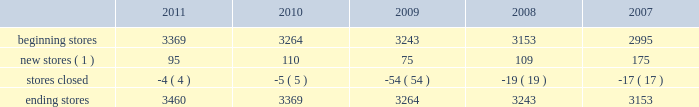The table sets forth information concerning increases in the total number of our aap stores during the past five years : beginning stores new stores ( 1 ) stores closed ending stores ( 1 ) does not include stores that opened as relocations of previously existing stores within the same general market area or substantial renovations of stores .
Our store-based information systems , which are designed to improve the efficiency of our operations and enhance customer service , are comprised of a proprietary pos system and electronic parts catalog , or epc , system .
Information maintained by our pos system is used to formulate pricing , marketing and merchandising strategies and to replenish inventory accurately and rapidly .
Our pos system is fully integrated with our epc system and enables our store team members to assist our customers in their parts selection and ordering based on the year , make , model and engine type of their vehicles .
Our centrally-based epc data management system enables us to reduce the time needed to ( i ) exchange data with our vendors and ( ii ) catalog and deliver updated , accurate parts information .
Our epc system also contains enhanced search engines and user-friendly navigation tools that enhance our team members' ability to look up any needed parts as well as additional products the customer needs to complete an automotive repair project .
If a hard-to-find part or accessory is not available at one of our stores , the epc system can determine whether the part is carried and in-stock through our hub or pdq ae networks or can be ordered directly from one of our vendors .
Available parts and accessories are then ordered electronically from another store , hub , pdq ae or directly from the vendor with immediate confirmation of price , availability and estimated delivery time .
We also support our store operations with additional proprietary systems and customer driven labor scheduling capabilities .
Our store-level inventory management system provides real-time inventory tracking at the store level .
With the store-level system , store team members can check the quantity of on-hand inventory for any sku , adjust stock levels for select items for store specific events , automatically process returns and defective merchandise , designate skus for cycle counts and track merchandise transfers .
Our stores use radio frequency hand-held devices to help ensure the accuracy of our inventory .
Our standard operating procedure , or sop , system is a web-based , electronic data management system that provides our team members with instant access to any of our standard operating procedures through a comprehensive on-line search function .
All of these systems are tightly integrated and provide real-time , comprehensive information to store personnel , resulting in improved customer service levels , team member productivity and in-stock availability .
Purchasing for virtually all of the merchandise for our stores is handled by our merchandise teams located in three primary locations : 2022 store support center in roanoke , virginia ; 2022 regional office in minneapolis , minnesota ; and 2022 global sourcing office in taipei , taiwan .
Our roanoke team is primarily responsible for the parts categories and our minnesota team is primarily responsible for accessories , oil and chemicals .
Our global sourcing team works closely with both teams .
In fiscal 2011 , we purchased merchandise from approximately 500 vendors , with no single vendor accounting for more than 9% ( 9 % ) of purchases .
Our purchasing strategy involves negotiating agreements with most of our vendors to purchase merchandise over a specified period of time along with other terms , including pricing , payment terms and volume .
The merchandising team has developed strong vendor relationships in the industry and , in a collaborative effort with our vendor partners , utilizes a category management process where we manage the mix of our product offerings to meet customer demand .
We believe this process , which develops a customer-focused business plan for each merchandise category , and our global sourcing operation are critical to improving comparable store sales , gross margin and inventory productivity. .
The following table sets forth information concerning increases in the total number of our aap stores during the past five years : beginning stores new stores ( 1 ) stores closed ending stores ( 1 ) does not include stores that opened as relocations of previously existing stores within the same general market area or substantial renovations of stores .
Our store-based information systems , which are designed to improve the efficiency of our operations and enhance customer service , are comprised of a proprietary pos system and electronic parts catalog , or epc , system .
Information maintained by our pos system is used to formulate pricing , marketing and merchandising strategies and to replenish inventory accurately and rapidly .
Our pos system is fully integrated with our epc system and enables our store team members to assist our customers in their parts selection and ordering based on the year , make , model and engine type of their vehicles .
Our centrally-based epc data management system enables us to reduce the time needed to ( i ) exchange data with our vendors and ( ii ) catalog and deliver updated , accurate parts information .
Our epc system also contains enhanced search engines and user-friendly navigation tools that enhance our team members' ability to look up any needed parts as well as additional products the customer needs to complete an automotive repair project .
If a hard-to-find part or accessory is not available at one of our stores , the epc system can determine whether the part is carried and in-stock through our hub or pdq ae networks or can be ordered directly from one of our vendors .
Available parts and accessories are then ordered electronically from another store , hub , pdq ae or directly from the vendor with immediate confirmation of price , availability and estimated delivery time .
We also support our store operations with additional proprietary systems and customer driven labor scheduling capabilities .
Our store-level inventory management system provides real-time inventory tracking at the store level .
With the store-level system , store team members can check the quantity of on-hand inventory for any sku , adjust stock levels for select items for store specific events , automatically process returns and defective merchandise , designate skus for cycle counts and track merchandise transfers .
Our stores use radio frequency hand-held devices to help ensure the accuracy of our inventory .
Our standard operating procedure , or sop , system is a web-based , electronic data management system that provides our team members with instant access to any of our standard operating procedures through a comprehensive on-line search function .
All of these systems are tightly integrated and provide real-time , comprehensive information to store personnel , resulting in improved customer service levels , team member productivity and in-stock availability .
Purchasing for virtually all of the merchandise for our stores is handled by our merchandise teams located in three primary locations : 2022 store support center in roanoke , virginia ; 2022 regional office in minneapolis , minnesota ; and 2022 global sourcing office in taipei , taiwan .
Our roanoke team is primarily responsible for the parts categories and our minnesota team is primarily responsible for accessories , oil and chemicals .
Our global sourcing team works closely with both teams .
In fiscal 2011 , we purchased merchandise from approximately 500 vendors , with no single vendor accounting for more than 9% ( 9 % ) of purchases .
Our purchasing strategy involves negotiating agreements with most of our vendors to purchase merchandise over a specified period of time along with other terms , including pricing , payment terms and volume .
The merchandising team has developed strong vendor relationships in the industry and , in a collaborative effort with our vendor partners , utilizes a category management process where we manage the mix of our product offerings to meet customer demand .
We believe this process , which develops a customer-focused business plan for each merchandise category , and our global sourcing operation are critical to improving comparable store sales , gross margin and inventory productivity. .
What was the average annual store closure from 2007 to 2011? 
Rationale: to find the average amount of closure of stores , one must add all of the closed stores for the years and divide by the amount of years .
Computations: ((17 + 4) / 2)
Answer: 10.5. 